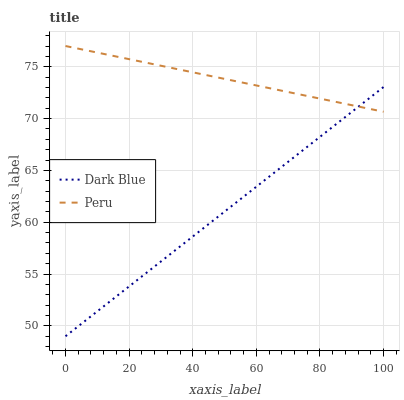Does Peru have the minimum area under the curve?
Answer yes or no. No. Is Peru the smoothest?
Answer yes or no. No. Does Peru have the lowest value?
Answer yes or no. No. 